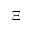<formula> <loc_0><loc_0><loc_500><loc_500>\Xi</formula> 